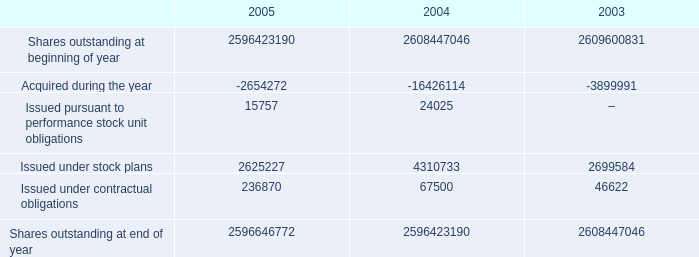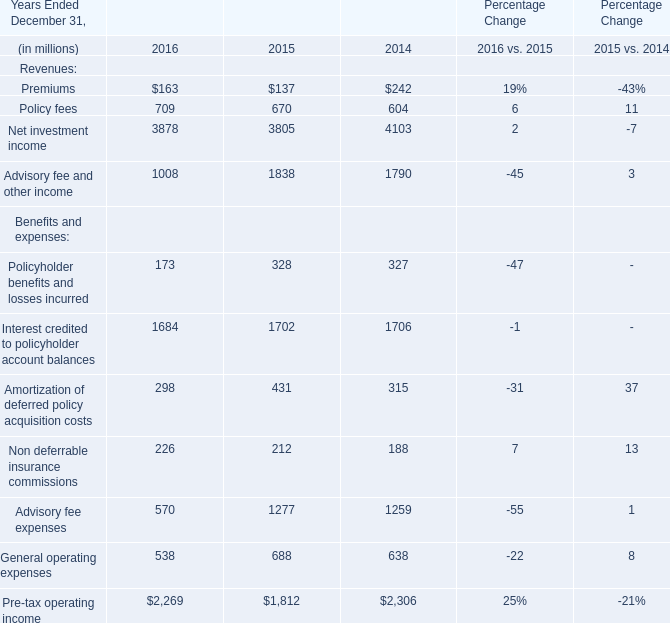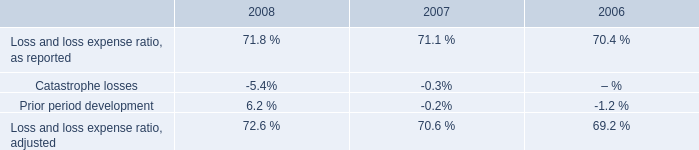In the year with lowest amount of Premiums in table 1, what's the increasing rate of Advisory fee and other income in table 1? 
Computations: ((1838 - 1790) / 1790)
Answer: 0.02682. 